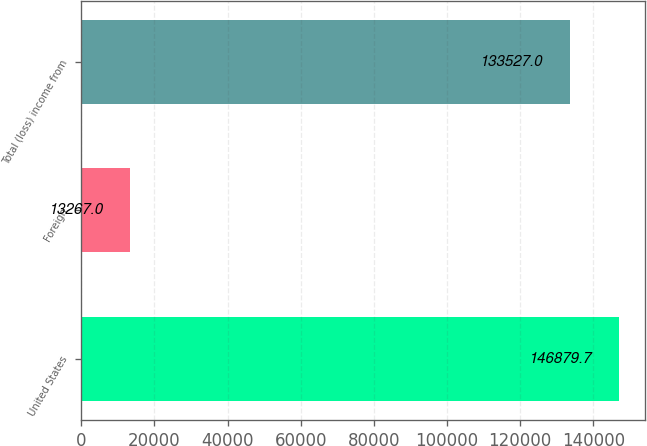Convert chart. <chart><loc_0><loc_0><loc_500><loc_500><bar_chart><fcel>United States<fcel>Foreign<fcel>Total (loss) income from<nl><fcel>146880<fcel>13267<fcel>133527<nl></chart> 